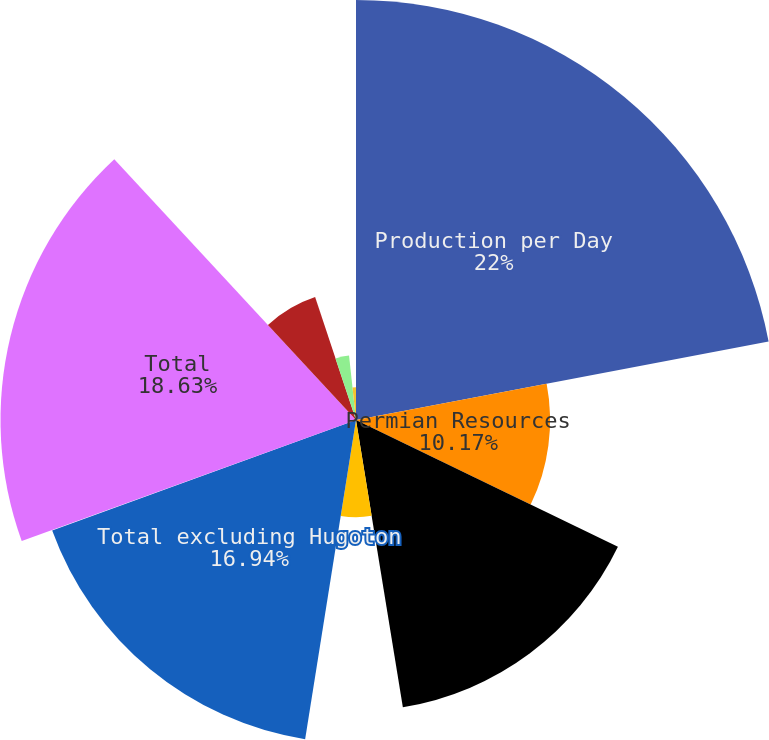<chart> <loc_0><loc_0><loc_500><loc_500><pie_chart><fcel>Production per Day<fcel>Permian Resources<fcel>Permian EOR<fcel>Midcontinent and Other<fcel>Total excluding Hugoton<fcel>Hugoton<fcel>Total<fcel>Oil (MBBL) - Colombia<fcel>Natural gas (MMCF) - Bolivia<fcel>Dolphin<nl><fcel>22.01%<fcel>10.17%<fcel>15.25%<fcel>5.09%<fcel>16.94%<fcel>0.02%<fcel>18.63%<fcel>6.79%<fcel>3.4%<fcel>1.71%<nl></chart> 